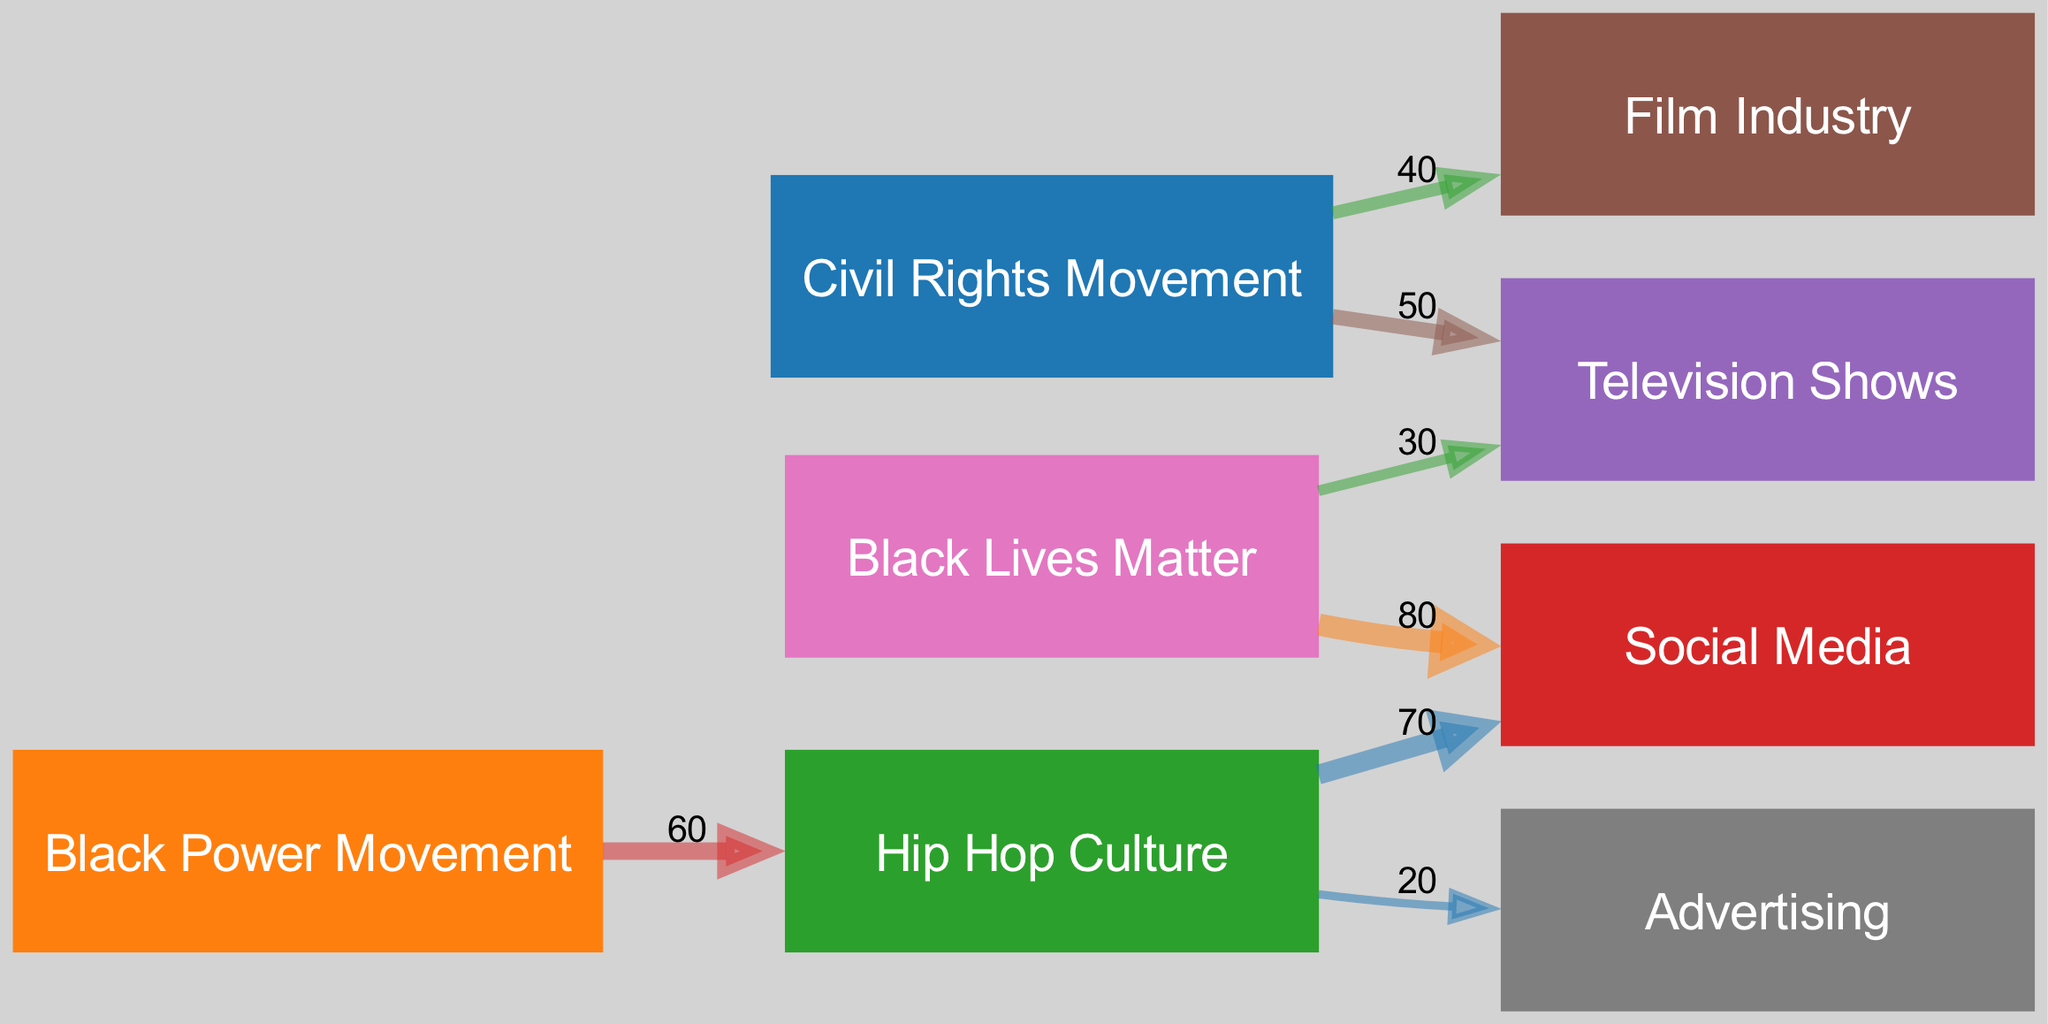What is the value of the link from the Civil Rights Movement to Television Shows? The diagram shows a link between the Civil Rights Movement and Television Shows with a value of 50. Therefore, the answer is directly taken from the link data provided in the diagram.
Answer: 50 Which movement is connected to Hip Hop Culture? The diagram indicates a connection from the Black Power Movement to Hip Hop Culture. This can be identified by looking for the source node of Hip Hop Culture in the links.
Answer: Black Power Movement How many nodes are present in the diagram? By counting the unique entities shown in the diagram's nodes section, we find there are eight. Each distinct node represents a significant aspect of African American movements and media platforms.
Answer: 8 What is the value of the connection between Hip Hop Culture and Social Media? The value of the link from Hip Hop Culture to Social Media can be found in the links section, where it indicates a value of 70. This link shows the influence of Hip Hop on Social Media platforms.
Answer: 70 Which media platform has the highest connection value from Black Lives Matter? Analyzing the links originating from Black Lives Matter, the highest connection is to Social Media with a value of 80. This indicates the strong relationship and influence of the Black Lives Matter movement on Social Media.
Answer: Social Media Which movement has the strongest influence on Advertising? The diagram reveals that Hip Hop Culture influences Advertising with a value of 20, which is the only link to Advertising and thus indicates the strongest influence.
Answer: Hip Hop Culture How does the flow of influence from the Civil Rights Movement to the Film Industry compare to that of the Civil Rights Movement to Television Shows? The flow shows a value of 40 for the Civil Rights Movement to Film Industry and a higher value of 50 to Television Shows. This indicates that the Civil Rights Movement had a greater influence on Television Shows than on the Film Industry when comparing the two specific links.
Answer: Greater influence on Television Shows What total value is contributed by the Black Lives Matter movement to Television Shows and Social Media combined? By summing the values of links from Black Lives Matter, which contributes 30 to Television Shows and 80 to Social Media, we can calculate the total contribution as 30 + 80 = 110. This explains the significant impact of Black Lives Matter on both platforms.
Answer: 110 Which cultural movement acts as a bridge to both Social Media and Advertising? The diagram shows that Hip Hop Culture connects both to Social Media with a value of 70 and to Advertising with a value of 20. This makes Hip Hop Culture the bridge between these two media platforms, linking the cultural movement to both.
Answer: Hip Hop Culture 